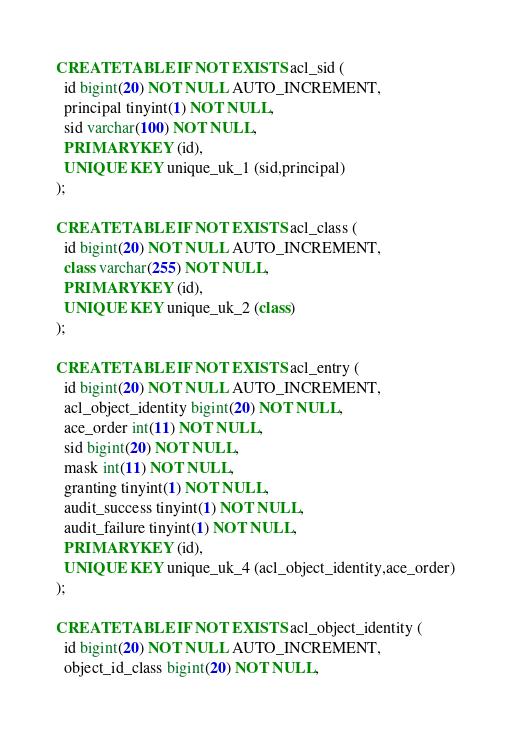Convert code to text. <code><loc_0><loc_0><loc_500><loc_500><_SQL_>CREATE TABLE IF NOT EXISTS acl_sid (
  id bigint(20) NOT NULL AUTO_INCREMENT,
  principal tinyint(1) NOT NULL,
  sid varchar(100) NOT NULL,
  PRIMARY KEY (id),
  UNIQUE KEY unique_uk_1 (sid,principal)
);

CREATE TABLE IF NOT EXISTS acl_class (
  id bigint(20) NOT NULL AUTO_INCREMENT,
  class varchar(255) NOT NULL,
  PRIMARY KEY (id),
  UNIQUE KEY unique_uk_2 (class)
);

CREATE TABLE IF NOT EXISTS acl_entry (
  id bigint(20) NOT NULL AUTO_INCREMENT,
  acl_object_identity bigint(20) NOT NULL,
  ace_order int(11) NOT NULL,
  sid bigint(20) NOT NULL,
  mask int(11) NOT NULL,
  granting tinyint(1) NOT NULL,
  audit_success tinyint(1) NOT NULL,
  audit_failure tinyint(1) NOT NULL,
  PRIMARY KEY (id),
  UNIQUE KEY unique_uk_4 (acl_object_identity,ace_order)
);

CREATE TABLE IF NOT EXISTS acl_object_identity (
  id bigint(20) NOT NULL AUTO_INCREMENT,
  object_id_class bigint(20) NOT NULL,</code> 